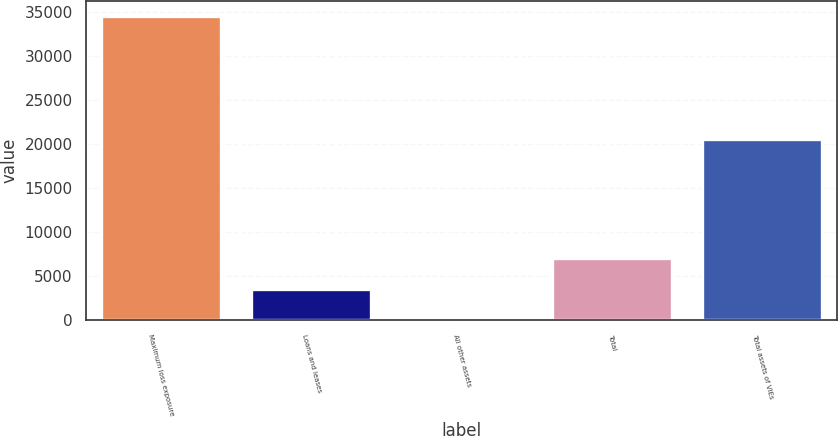Convert chart to OTSL. <chart><loc_0><loc_0><loc_500><loc_500><bar_chart><fcel>Maximum loss exposure<fcel>Loans and leases<fcel>All other assets<fcel>Total<fcel>Total assets of VIEs<nl><fcel>34523<fcel>3509.9<fcel>64<fcel>7091<fcel>20606<nl></chart> 